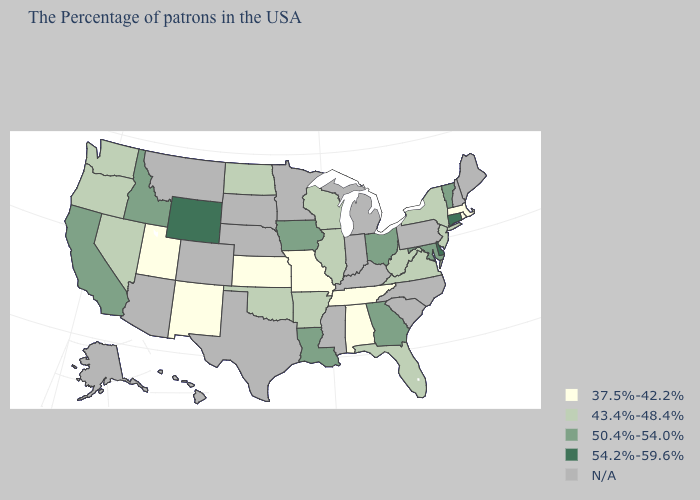Does the map have missing data?
Quick response, please. Yes. Which states hav the highest value in the MidWest?
Answer briefly. Ohio, Iowa. Name the states that have a value in the range 50.4%-54.0%?
Be succinct. Vermont, Maryland, Ohio, Georgia, Louisiana, Iowa, Idaho, California. What is the highest value in the USA?
Concise answer only. 54.2%-59.6%. Does Connecticut have the highest value in the USA?
Concise answer only. Yes. Which states have the lowest value in the USA?
Keep it brief. Massachusetts, Rhode Island, Alabama, Tennessee, Missouri, Kansas, New Mexico, Utah. What is the highest value in states that border West Virginia?
Concise answer only. 50.4%-54.0%. Which states hav the highest value in the MidWest?
Answer briefly. Ohio, Iowa. Which states have the lowest value in the USA?
Write a very short answer. Massachusetts, Rhode Island, Alabama, Tennessee, Missouri, Kansas, New Mexico, Utah. What is the lowest value in states that border Georgia?
Write a very short answer. 37.5%-42.2%. What is the value of North Dakota?
Concise answer only. 43.4%-48.4%. Which states hav the highest value in the MidWest?
Concise answer only. Ohio, Iowa. What is the value of Utah?
Concise answer only. 37.5%-42.2%. 